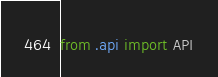<code> <loc_0><loc_0><loc_500><loc_500><_Python_>from .api import API
</code> 